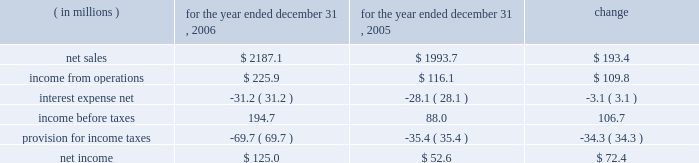Results of operations year ended december 31 , 2006 compared to year ended december 31 , 2005 the historical results of operations of pca for the years ended december 31 , 2006 and 2005 are set forth below : for the year ended december 31 , ( in millions ) 2006 2005 change .
Net sales net sales increased by $ 193.4 million , or 9.7% ( 9.7 % ) , for the year ended december 31 , 2006 from the year ended december 31 , 2005 .
Net sales increased primarily due to increased sales prices and volumes of corrugated products and containerboard compared to 2005 .
Total corrugated products volume sold increased 0.4% ( 0.4 % ) to 31.3 billion square feet in 2006 compared to 31.2 billion square feet in 2005 .
On a comparable shipment-per-workday basis , corrugated products sales volume increased 0.8% ( 0.8 % ) in 2006 from 2005 .
Shipments-per-workday is calculated by dividing our total corrugated products volume during the year by the number of workdays within the year .
The larger percentage increase on a shipment-per-workday basis was due to the fact that 2006 had one less workday ( 249 days ) , those days not falling on a weekend or holiday , than 2005 ( 250 days ) .
Containerboard sales volume to external domestic and export customers increased 15.6% ( 15.6 % ) to 482000 tons for the year ended december 31 , 2006 from 417000 tons in 2005 .
Income from operations income from operations increased by $ 109.8 million , or 94.6% ( 94.6 % ) , for the year ended december 31 , 2006 compared to 2005 .
Included in income from operations for the year ended december 31 , 2005 is income of $ 14.0 million , net of expenses , consisting of two dividends paid to pca by southern timber venture , llc ( stv ) , the timberlands joint venture in which pca owns a 311 20443% ( 20443 % ) ownership interest .
Excluding the dividends from stv , income from operations increased $ 123.8 million in 2006 compared to 2005 .
The $ 123.8 million increase in income from operations was primarily attributable to higher sales prices and volume as well as improved mix of business ( $ 195.6 million ) , partially offset by increased costs related to transportation ( $ 18.9 million ) , energy , primarily purchased fuels and electricity ( $ 18.3 million ) , wage increases for hourly and salaried personnel ( $ 16.9 million ) , medical , pension and other benefit costs ( $ 9.9 million ) , and incentive compensation ( $ 6.5 million ) .
Gross profit increased $ 137.1 million , or 44.7% ( 44.7 % ) , for the year ended december 31 , 2006 from the year ended december 31 , 2005 .
Gross profit as a percentage of net sales increased from 15.4% ( 15.4 % ) of net sales in 2005 to 20.3% ( 20.3 % ) of net sales in the current year primarily due to the increased sales prices described previously .
Selling and administrative expenses increased $ 12.3 million , or 8.4% ( 8.4 % ) , for the year ended december 31 , 2006 from the comparable period in 2005 .
The increase was primarily the result of increased salary and .
Net sales increased by what percent from 2005 to 2006? 
Computations: (193.4 / 1993.7)
Answer: 0.09701. Results of operations year ended december 31 , 2006 compared to year ended december 31 , 2005 the historical results of operations of pca for the years ended december 31 , 2006 and 2005 are set forth below : for the year ended december 31 , ( in millions ) 2006 2005 change .
Net sales net sales increased by $ 193.4 million , or 9.7% ( 9.7 % ) , for the year ended december 31 , 2006 from the year ended december 31 , 2005 .
Net sales increased primarily due to increased sales prices and volumes of corrugated products and containerboard compared to 2005 .
Total corrugated products volume sold increased 0.4% ( 0.4 % ) to 31.3 billion square feet in 2006 compared to 31.2 billion square feet in 2005 .
On a comparable shipment-per-workday basis , corrugated products sales volume increased 0.8% ( 0.8 % ) in 2006 from 2005 .
Shipments-per-workday is calculated by dividing our total corrugated products volume during the year by the number of workdays within the year .
The larger percentage increase on a shipment-per-workday basis was due to the fact that 2006 had one less workday ( 249 days ) , those days not falling on a weekend or holiday , than 2005 ( 250 days ) .
Containerboard sales volume to external domestic and export customers increased 15.6% ( 15.6 % ) to 482000 tons for the year ended december 31 , 2006 from 417000 tons in 2005 .
Income from operations income from operations increased by $ 109.8 million , or 94.6% ( 94.6 % ) , for the year ended december 31 , 2006 compared to 2005 .
Included in income from operations for the year ended december 31 , 2005 is income of $ 14.0 million , net of expenses , consisting of two dividends paid to pca by southern timber venture , llc ( stv ) , the timberlands joint venture in which pca owns a 311 20443% ( 20443 % ) ownership interest .
Excluding the dividends from stv , income from operations increased $ 123.8 million in 2006 compared to 2005 .
The $ 123.8 million increase in income from operations was primarily attributable to higher sales prices and volume as well as improved mix of business ( $ 195.6 million ) , partially offset by increased costs related to transportation ( $ 18.9 million ) , energy , primarily purchased fuels and electricity ( $ 18.3 million ) , wage increases for hourly and salaried personnel ( $ 16.9 million ) , medical , pension and other benefit costs ( $ 9.9 million ) , and incentive compensation ( $ 6.5 million ) .
Gross profit increased $ 137.1 million , or 44.7% ( 44.7 % ) , for the year ended december 31 , 2006 from the year ended december 31 , 2005 .
Gross profit as a percentage of net sales increased from 15.4% ( 15.4 % ) of net sales in 2005 to 20.3% ( 20.3 % ) of net sales in the current year primarily due to the increased sales prices described previously .
Selling and administrative expenses increased $ 12.3 million , or 8.4% ( 8.4 % ) , for the year ended december 31 , 2006 from the comparable period in 2005 .
The increase was primarily the result of increased salary and .
What was the operating income margin for 2005? 
Computations: (116.1 / 1993.7)
Answer: 0.05823. 